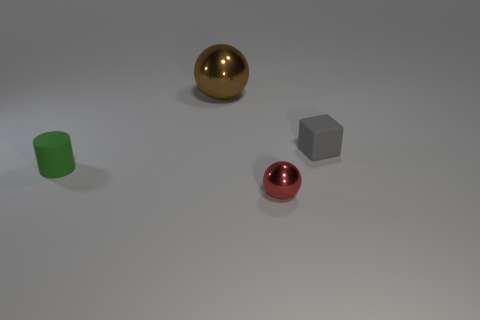Add 2 brown metallic things. How many objects exist? 6 Subtract all blocks. How many objects are left? 3 Subtract all small green rubber cylinders. Subtract all brown objects. How many objects are left? 2 Add 4 cylinders. How many cylinders are left? 5 Add 1 large green objects. How many large green objects exist? 1 Subtract 1 red spheres. How many objects are left? 3 